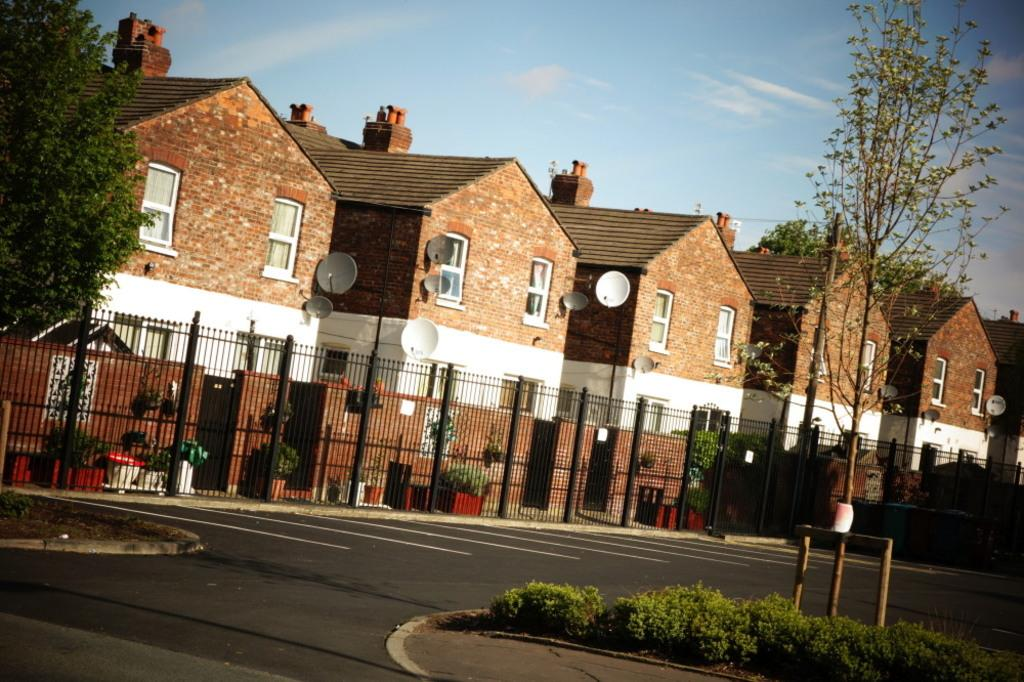What type of structures can be seen in the image? There are buildings in the image. What architectural features are visible on the buildings? Windows and satellite dishes attached to the wall are visible on the buildings. What type of vegetation is present in the image? There are trees in the image. What type of barrier is present in the image? There is a railing in the image. What objects are used for decoration in the image? Flower pots are present in the image for decoration. What type of surface can be seen in the image? There is a road in the image. What part of the natural environment is visible in the image? The sky is visible in the image. What type of fowl can be seen crying near the crook in the image? There is no fowl or crook present in the image. 